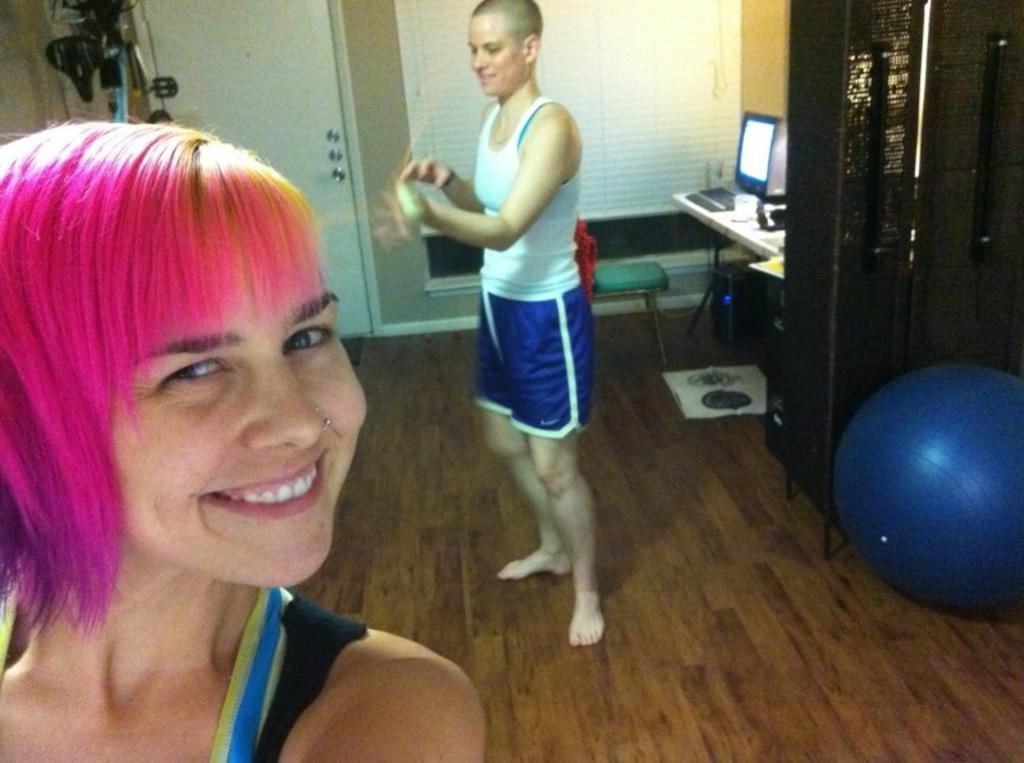How many people are present in the image? There are two people in the image. What is behind the people in the image? There is a glass wall behind the people. What electronic device can be seen on a table in the image? There is a computer on a table in the image. What type of furniture is present in the image? There is a cupboard in the image. What object is round and can be bounced in the image? There is a ball in the image. What type of fish is swimming in the cupboard in the image? There are no fish present in the image, and the cupboard is not a body of water where fish could swim. 